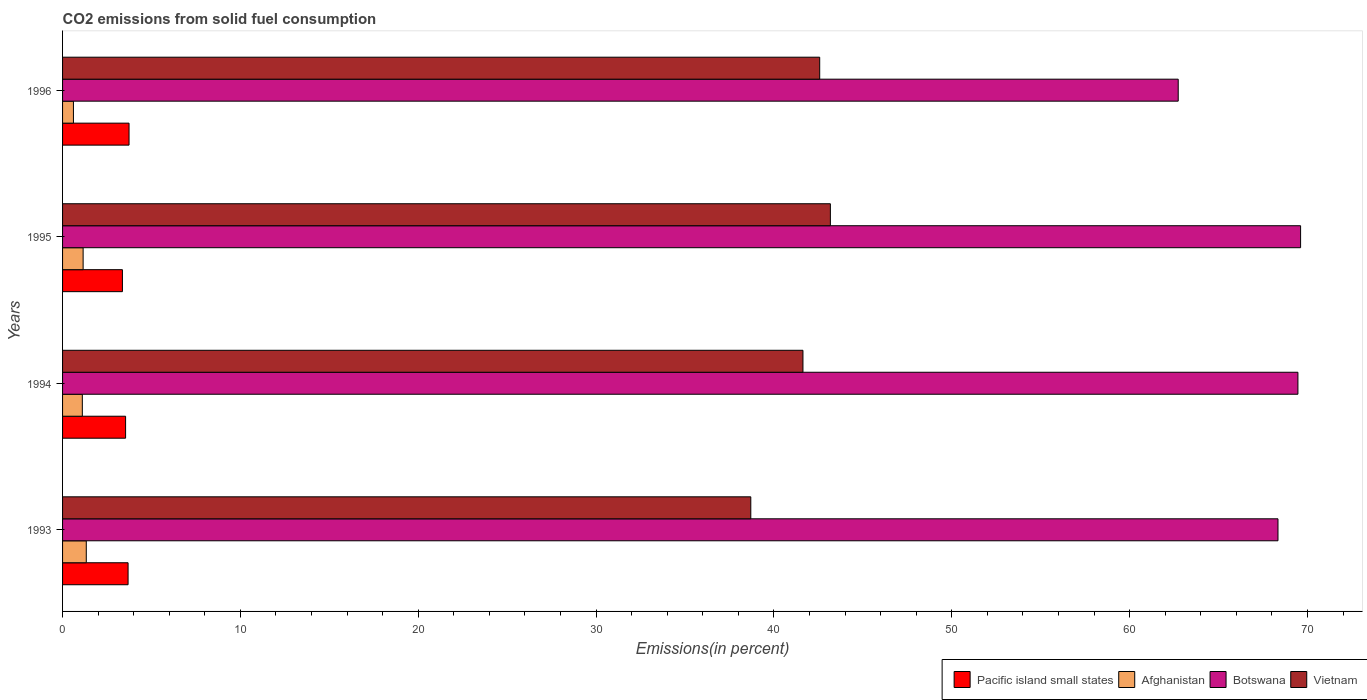What is the total CO2 emitted in Vietnam in 1994?
Offer a very short reply. 41.63. Across all years, what is the maximum total CO2 emitted in Botswana?
Your answer should be compact. 69.61. Across all years, what is the minimum total CO2 emitted in Afghanistan?
Provide a succinct answer. 0.61. In which year was the total CO2 emitted in Vietnam maximum?
Give a very brief answer. 1995. What is the total total CO2 emitted in Botswana in the graph?
Offer a terse response. 270.16. What is the difference between the total CO2 emitted in Vietnam in 1993 and that in 1995?
Offer a terse response. -4.47. What is the difference between the total CO2 emitted in Botswana in 1996 and the total CO2 emitted in Vietnam in 1995?
Offer a terse response. 19.56. What is the average total CO2 emitted in Pacific island small states per year?
Give a very brief answer. 3.58. In the year 1994, what is the difference between the total CO2 emitted in Vietnam and total CO2 emitted in Afghanistan?
Offer a terse response. 40.52. In how many years, is the total CO2 emitted in Vietnam greater than 36 %?
Offer a terse response. 4. What is the ratio of the total CO2 emitted in Afghanistan in 1993 to that in 1995?
Keep it short and to the point. 1.15. What is the difference between the highest and the second highest total CO2 emitted in Botswana?
Your answer should be compact. 0.15. What is the difference between the highest and the lowest total CO2 emitted in Botswana?
Make the answer very short. 6.88. Is the sum of the total CO2 emitted in Vietnam in 1993 and 1995 greater than the maximum total CO2 emitted in Botswana across all years?
Your response must be concise. Yes. What does the 1st bar from the top in 1995 represents?
Your answer should be compact. Vietnam. What does the 4th bar from the bottom in 1994 represents?
Give a very brief answer. Vietnam. Are all the bars in the graph horizontal?
Give a very brief answer. Yes. Where does the legend appear in the graph?
Offer a terse response. Bottom right. How are the legend labels stacked?
Keep it short and to the point. Horizontal. What is the title of the graph?
Provide a succinct answer. CO2 emissions from solid fuel consumption. What is the label or title of the X-axis?
Provide a short and direct response. Emissions(in percent). What is the label or title of the Y-axis?
Keep it short and to the point. Years. What is the Emissions(in percent) in Pacific island small states in 1993?
Provide a succinct answer. 3.68. What is the Emissions(in percent) in Afghanistan in 1993?
Offer a terse response. 1.33. What is the Emissions(in percent) of Botswana in 1993?
Make the answer very short. 68.34. What is the Emissions(in percent) of Vietnam in 1993?
Provide a short and direct response. 38.7. What is the Emissions(in percent) in Pacific island small states in 1994?
Ensure brevity in your answer.  3.54. What is the Emissions(in percent) of Afghanistan in 1994?
Provide a short and direct response. 1.11. What is the Emissions(in percent) of Botswana in 1994?
Give a very brief answer. 69.46. What is the Emissions(in percent) of Vietnam in 1994?
Ensure brevity in your answer.  41.63. What is the Emissions(in percent) in Pacific island small states in 1995?
Ensure brevity in your answer.  3.37. What is the Emissions(in percent) in Afghanistan in 1995?
Your answer should be compact. 1.16. What is the Emissions(in percent) of Botswana in 1995?
Provide a short and direct response. 69.61. What is the Emissions(in percent) of Vietnam in 1995?
Ensure brevity in your answer.  43.17. What is the Emissions(in percent) of Pacific island small states in 1996?
Your answer should be very brief. 3.74. What is the Emissions(in percent) of Afghanistan in 1996?
Offer a terse response. 0.61. What is the Emissions(in percent) of Botswana in 1996?
Make the answer very short. 62.73. What is the Emissions(in percent) of Vietnam in 1996?
Your answer should be compact. 42.57. Across all years, what is the maximum Emissions(in percent) of Pacific island small states?
Provide a succinct answer. 3.74. Across all years, what is the maximum Emissions(in percent) of Afghanistan?
Ensure brevity in your answer.  1.33. Across all years, what is the maximum Emissions(in percent) in Botswana?
Make the answer very short. 69.61. Across all years, what is the maximum Emissions(in percent) in Vietnam?
Make the answer very short. 43.17. Across all years, what is the minimum Emissions(in percent) of Pacific island small states?
Your answer should be compact. 3.37. Across all years, what is the minimum Emissions(in percent) in Afghanistan?
Offer a terse response. 0.61. Across all years, what is the minimum Emissions(in percent) in Botswana?
Keep it short and to the point. 62.73. Across all years, what is the minimum Emissions(in percent) of Vietnam?
Ensure brevity in your answer.  38.7. What is the total Emissions(in percent) of Pacific island small states in the graph?
Offer a terse response. 14.33. What is the total Emissions(in percent) in Afghanistan in the graph?
Keep it short and to the point. 4.21. What is the total Emissions(in percent) in Botswana in the graph?
Your answer should be compact. 270.16. What is the total Emissions(in percent) in Vietnam in the graph?
Make the answer very short. 166.08. What is the difference between the Emissions(in percent) of Pacific island small states in 1993 and that in 1994?
Give a very brief answer. 0.14. What is the difference between the Emissions(in percent) in Afghanistan in 1993 and that in 1994?
Make the answer very short. 0.22. What is the difference between the Emissions(in percent) of Botswana in 1993 and that in 1994?
Provide a succinct answer. -1.12. What is the difference between the Emissions(in percent) in Vietnam in 1993 and that in 1994?
Provide a succinct answer. -2.93. What is the difference between the Emissions(in percent) of Pacific island small states in 1993 and that in 1995?
Provide a short and direct response. 0.32. What is the difference between the Emissions(in percent) of Afghanistan in 1993 and that in 1995?
Make the answer very short. 0.18. What is the difference between the Emissions(in percent) of Botswana in 1993 and that in 1995?
Offer a terse response. -1.27. What is the difference between the Emissions(in percent) of Vietnam in 1993 and that in 1995?
Keep it short and to the point. -4.47. What is the difference between the Emissions(in percent) of Pacific island small states in 1993 and that in 1996?
Your answer should be compact. -0.05. What is the difference between the Emissions(in percent) of Afghanistan in 1993 and that in 1996?
Your answer should be compact. 0.72. What is the difference between the Emissions(in percent) in Botswana in 1993 and that in 1996?
Make the answer very short. 5.61. What is the difference between the Emissions(in percent) of Vietnam in 1993 and that in 1996?
Provide a short and direct response. -3.88. What is the difference between the Emissions(in percent) in Pacific island small states in 1994 and that in 1995?
Your answer should be compact. 0.18. What is the difference between the Emissions(in percent) of Afghanistan in 1994 and that in 1995?
Your answer should be very brief. -0.04. What is the difference between the Emissions(in percent) in Botswana in 1994 and that in 1995?
Your response must be concise. -0.15. What is the difference between the Emissions(in percent) in Vietnam in 1994 and that in 1995?
Your answer should be very brief. -1.54. What is the difference between the Emissions(in percent) of Pacific island small states in 1994 and that in 1996?
Keep it short and to the point. -0.19. What is the difference between the Emissions(in percent) in Afghanistan in 1994 and that in 1996?
Provide a succinct answer. 0.5. What is the difference between the Emissions(in percent) in Botswana in 1994 and that in 1996?
Provide a succinct answer. 6.73. What is the difference between the Emissions(in percent) of Vietnam in 1994 and that in 1996?
Offer a terse response. -0.94. What is the difference between the Emissions(in percent) in Pacific island small states in 1995 and that in 1996?
Keep it short and to the point. -0.37. What is the difference between the Emissions(in percent) in Afghanistan in 1995 and that in 1996?
Your answer should be very brief. 0.54. What is the difference between the Emissions(in percent) of Botswana in 1995 and that in 1996?
Your answer should be compact. 6.88. What is the difference between the Emissions(in percent) in Vietnam in 1995 and that in 1996?
Ensure brevity in your answer.  0.6. What is the difference between the Emissions(in percent) in Pacific island small states in 1993 and the Emissions(in percent) in Afghanistan in 1994?
Make the answer very short. 2.57. What is the difference between the Emissions(in percent) of Pacific island small states in 1993 and the Emissions(in percent) of Botswana in 1994?
Make the answer very short. -65.78. What is the difference between the Emissions(in percent) in Pacific island small states in 1993 and the Emissions(in percent) in Vietnam in 1994?
Your answer should be very brief. -37.95. What is the difference between the Emissions(in percent) in Afghanistan in 1993 and the Emissions(in percent) in Botswana in 1994?
Your answer should be very brief. -68.13. What is the difference between the Emissions(in percent) in Afghanistan in 1993 and the Emissions(in percent) in Vietnam in 1994?
Offer a very short reply. -40.3. What is the difference between the Emissions(in percent) of Botswana in 1993 and the Emissions(in percent) of Vietnam in 1994?
Your answer should be compact. 26.71. What is the difference between the Emissions(in percent) in Pacific island small states in 1993 and the Emissions(in percent) in Afghanistan in 1995?
Offer a terse response. 2.53. What is the difference between the Emissions(in percent) of Pacific island small states in 1993 and the Emissions(in percent) of Botswana in 1995?
Ensure brevity in your answer.  -65.93. What is the difference between the Emissions(in percent) in Pacific island small states in 1993 and the Emissions(in percent) in Vietnam in 1995?
Keep it short and to the point. -39.49. What is the difference between the Emissions(in percent) of Afghanistan in 1993 and the Emissions(in percent) of Botswana in 1995?
Offer a terse response. -68.28. What is the difference between the Emissions(in percent) in Afghanistan in 1993 and the Emissions(in percent) in Vietnam in 1995?
Provide a short and direct response. -41.84. What is the difference between the Emissions(in percent) in Botswana in 1993 and the Emissions(in percent) in Vietnam in 1995?
Your response must be concise. 25.17. What is the difference between the Emissions(in percent) of Pacific island small states in 1993 and the Emissions(in percent) of Afghanistan in 1996?
Your response must be concise. 3.07. What is the difference between the Emissions(in percent) of Pacific island small states in 1993 and the Emissions(in percent) of Botswana in 1996?
Provide a succinct answer. -59.05. What is the difference between the Emissions(in percent) of Pacific island small states in 1993 and the Emissions(in percent) of Vietnam in 1996?
Give a very brief answer. -38.89. What is the difference between the Emissions(in percent) in Afghanistan in 1993 and the Emissions(in percent) in Botswana in 1996?
Provide a short and direct response. -61.4. What is the difference between the Emissions(in percent) of Afghanistan in 1993 and the Emissions(in percent) of Vietnam in 1996?
Your response must be concise. -41.24. What is the difference between the Emissions(in percent) of Botswana in 1993 and the Emissions(in percent) of Vietnam in 1996?
Your response must be concise. 25.77. What is the difference between the Emissions(in percent) in Pacific island small states in 1994 and the Emissions(in percent) in Afghanistan in 1995?
Make the answer very short. 2.39. What is the difference between the Emissions(in percent) in Pacific island small states in 1994 and the Emissions(in percent) in Botswana in 1995?
Keep it short and to the point. -66.07. What is the difference between the Emissions(in percent) in Pacific island small states in 1994 and the Emissions(in percent) in Vietnam in 1995?
Your answer should be compact. -39.63. What is the difference between the Emissions(in percent) in Afghanistan in 1994 and the Emissions(in percent) in Botswana in 1995?
Provide a succinct answer. -68.5. What is the difference between the Emissions(in percent) of Afghanistan in 1994 and the Emissions(in percent) of Vietnam in 1995?
Provide a succinct answer. -42.06. What is the difference between the Emissions(in percent) in Botswana in 1994 and the Emissions(in percent) in Vietnam in 1995?
Your answer should be compact. 26.29. What is the difference between the Emissions(in percent) of Pacific island small states in 1994 and the Emissions(in percent) of Afghanistan in 1996?
Your response must be concise. 2.93. What is the difference between the Emissions(in percent) in Pacific island small states in 1994 and the Emissions(in percent) in Botswana in 1996?
Offer a terse response. -59.19. What is the difference between the Emissions(in percent) in Pacific island small states in 1994 and the Emissions(in percent) in Vietnam in 1996?
Keep it short and to the point. -39.03. What is the difference between the Emissions(in percent) of Afghanistan in 1994 and the Emissions(in percent) of Botswana in 1996?
Keep it short and to the point. -61.62. What is the difference between the Emissions(in percent) of Afghanistan in 1994 and the Emissions(in percent) of Vietnam in 1996?
Offer a terse response. -41.46. What is the difference between the Emissions(in percent) of Botswana in 1994 and the Emissions(in percent) of Vietnam in 1996?
Provide a succinct answer. 26.89. What is the difference between the Emissions(in percent) of Pacific island small states in 1995 and the Emissions(in percent) of Afghanistan in 1996?
Offer a very short reply. 2.75. What is the difference between the Emissions(in percent) in Pacific island small states in 1995 and the Emissions(in percent) in Botswana in 1996?
Offer a terse response. -59.37. What is the difference between the Emissions(in percent) in Pacific island small states in 1995 and the Emissions(in percent) in Vietnam in 1996?
Your answer should be very brief. -39.21. What is the difference between the Emissions(in percent) of Afghanistan in 1995 and the Emissions(in percent) of Botswana in 1996?
Give a very brief answer. -61.58. What is the difference between the Emissions(in percent) of Afghanistan in 1995 and the Emissions(in percent) of Vietnam in 1996?
Make the answer very short. -41.42. What is the difference between the Emissions(in percent) in Botswana in 1995 and the Emissions(in percent) in Vietnam in 1996?
Ensure brevity in your answer.  27.04. What is the average Emissions(in percent) of Pacific island small states per year?
Provide a short and direct response. 3.58. What is the average Emissions(in percent) of Afghanistan per year?
Give a very brief answer. 1.05. What is the average Emissions(in percent) in Botswana per year?
Your answer should be compact. 67.54. What is the average Emissions(in percent) in Vietnam per year?
Provide a short and direct response. 41.52. In the year 1993, what is the difference between the Emissions(in percent) of Pacific island small states and Emissions(in percent) of Afghanistan?
Your response must be concise. 2.35. In the year 1993, what is the difference between the Emissions(in percent) in Pacific island small states and Emissions(in percent) in Botswana?
Provide a short and direct response. -64.66. In the year 1993, what is the difference between the Emissions(in percent) in Pacific island small states and Emissions(in percent) in Vietnam?
Provide a short and direct response. -35.02. In the year 1993, what is the difference between the Emissions(in percent) of Afghanistan and Emissions(in percent) of Botswana?
Provide a succinct answer. -67.01. In the year 1993, what is the difference between the Emissions(in percent) in Afghanistan and Emissions(in percent) in Vietnam?
Offer a very short reply. -37.37. In the year 1993, what is the difference between the Emissions(in percent) of Botswana and Emissions(in percent) of Vietnam?
Offer a terse response. 29.64. In the year 1994, what is the difference between the Emissions(in percent) in Pacific island small states and Emissions(in percent) in Afghanistan?
Ensure brevity in your answer.  2.43. In the year 1994, what is the difference between the Emissions(in percent) in Pacific island small states and Emissions(in percent) in Botswana?
Offer a very short reply. -65.92. In the year 1994, what is the difference between the Emissions(in percent) of Pacific island small states and Emissions(in percent) of Vietnam?
Offer a very short reply. -38.09. In the year 1994, what is the difference between the Emissions(in percent) of Afghanistan and Emissions(in percent) of Botswana?
Your answer should be compact. -68.35. In the year 1994, what is the difference between the Emissions(in percent) of Afghanistan and Emissions(in percent) of Vietnam?
Your answer should be compact. -40.52. In the year 1994, what is the difference between the Emissions(in percent) of Botswana and Emissions(in percent) of Vietnam?
Make the answer very short. 27.83. In the year 1995, what is the difference between the Emissions(in percent) in Pacific island small states and Emissions(in percent) in Afghanistan?
Offer a terse response. 2.21. In the year 1995, what is the difference between the Emissions(in percent) of Pacific island small states and Emissions(in percent) of Botswana?
Make the answer very short. -66.25. In the year 1995, what is the difference between the Emissions(in percent) in Pacific island small states and Emissions(in percent) in Vietnam?
Your answer should be compact. -39.81. In the year 1995, what is the difference between the Emissions(in percent) of Afghanistan and Emissions(in percent) of Botswana?
Give a very brief answer. -68.46. In the year 1995, what is the difference between the Emissions(in percent) of Afghanistan and Emissions(in percent) of Vietnam?
Provide a succinct answer. -42.02. In the year 1995, what is the difference between the Emissions(in percent) in Botswana and Emissions(in percent) in Vietnam?
Provide a short and direct response. 26.44. In the year 1996, what is the difference between the Emissions(in percent) of Pacific island small states and Emissions(in percent) of Afghanistan?
Ensure brevity in your answer.  3.13. In the year 1996, what is the difference between the Emissions(in percent) in Pacific island small states and Emissions(in percent) in Botswana?
Keep it short and to the point. -59. In the year 1996, what is the difference between the Emissions(in percent) of Pacific island small states and Emissions(in percent) of Vietnam?
Give a very brief answer. -38.84. In the year 1996, what is the difference between the Emissions(in percent) of Afghanistan and Emissions(in percent) of Botswana?
Your answer should be very brief. -62.12. In the year 1996, what is the difference between the Emissions(in percent) of Afghanistan and Emissions(in percent) of Vietnam?
Give a very brief answer. -41.96. In the year 1996, what is the difference between the Emissions(in percent) of Botswana and Emissions(in percent) of Vietnam?
Your answer should be compact. 20.16. What is the ratio of the Emissions(in percent) in Pacific island small states in 1993 to that in 1994?
Offer a terse response. 1.04. What is the ratio of the Emissions(in percent) in Botswana in 1993 to that in 1994?
Your answer should be compact. 0.98. What is the ratio of the Emissions(in percent) in Vietnam in 1993 to that in 1994?
Offer a very short reply. 0.93. What is the ratio of the Emissions(in percent) of Pacific island small states in 1993 to that in 1995?
Your response must be concise. 1.09. What is the ratio of the Emissions(in percent) of Afghanistan in 1993 to that in 1995?
Keep it short and to the point. 1.15. What is the ratio of the Emissions(in percent) in Botswana in 1993 to that in 1995?
Provide a short and direct response. 0.98. What is the ratio of the Emissions(in percent) of Vietnam in 1993 to that in 1995?
Your response must be concise. 0.9. What is the ratio of the Emissions(in percent) in Pacific island small states in 1993 to that in 1996?
Make the answer very short. 0.99. What is the ratio of the Emissions(in percent) in Afghanistan in 1993 to that in 1996?
Your response must be concise. 2.18. What is the ratio of the Emissions(in percent) of Botswana in 1993 to that in 1996?
Give a very brief answer. 1.09. What is the ratio of the Emissions(in percent) in Vietnam in 1993 to that in 1996?
Your answer should be compact. 0.91. What is the ratio of the Emissions(in percent) of Pacific island small states in 1994 to that in 1995?
Your response must be concise. 1.05. What is the ratio of the Emissions(in percent) of Afghanistan in 1994 to that in 1995?
Provide a succinct answer. 0.96. What is the ratio of the Emissions(in percent) in Botswana in 1994 to that in 1995?
Provide a succinct answer. 1. What is the ratio of the Emissions(in percent) in Vietnam in 1994 to that in 1995?
Your answer should be compact. 0.96. What is the ratio of the Emissions(in percent) in Pacific island small states in 1994 to that in 1996?
Your response must be concise. 0.95. What is the ratio of the Emissions(in percent) of Afghanistan in 1994 to that in 1996?
Make the answer very short. 1.82. What is the ratio of the Emissions(in percent) in Botswana in 1994 to that in 1996?
Provide a short and direct response. 1.11. What is the ratio of the Emissions(in percent) of Vietnam in 1994 to that in 1996?
Your answer should be very brief. 0.98. What is the ratio of the Emissions(in percent) in Pacific island small states in 1995 to that in 1996?
Make the answer very short. 0.9. What is the ratio of the Emissions(in percent) of Afghanistan in 1995 to that in 1996?
Offer a very short reply. 1.89. What is the ratio of the Emissions(in percent) in Botswana in 1995 to that in 1996?
Provide a succinct answer. 1.11. What is the ratio of the Emissions(in percent) in Vietnam in 1995 to that in 1996?
Your answer should be compact. 1.01. What is the difference between the highest and the second highest Emissions(in percent) of Pacific island small states?
Keep it short and to the point. 0.05. What is the difference between the highest and the second highest Emissions(in percent) of Afghanistan?
Your answer should be very brief. 0.18. What is the difference between the highest and the second highest Emissions(in percent) of Botswana?
Keep it short and to the point. 0.15. What is the difference between the highest and the second highest Emissions(in percent) of Vietnam?
Your answer should be compact. 0.6. What is the difference between the highest and the lowest Emissions(in percent) in Pacific island small states?
Offer a terse response. 0.37. What is the difference between the highest and the lowest Emissions(in percent) in Afghanistan?
Offer a terse response. 0.72. What is the difference between the highest and the lowest Emissions(in percent) in Botswana?
Offer a very short reply. 6.88. What is the difference between the highest and the lowest Emissions(in percent) in Vietnam?
Keep it short and to the point. 4.47. 